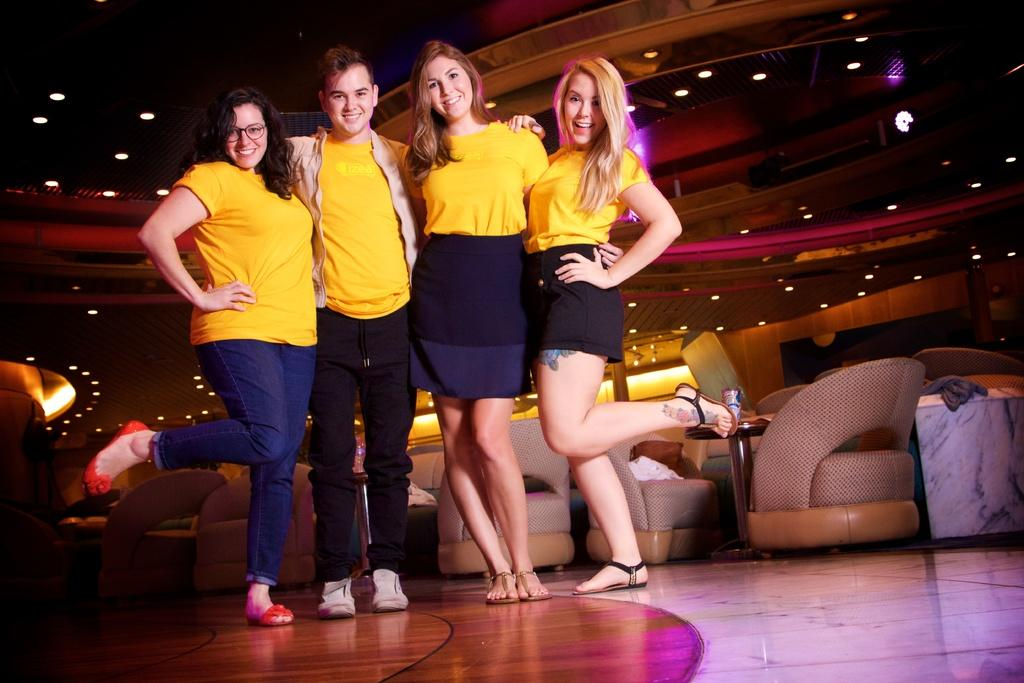How many people are in the image? There are four persons in the image. What are the people wearing? The persons are wearing yellow t-shirts. What can be seen in the background of the image? There are chairs in the background of the image. What is located at the top of the image? There are lights at the top of the image. What type of yarn is being used to measure the distance between the persons in the image? There is no yarn or measuring activity present in the image. 